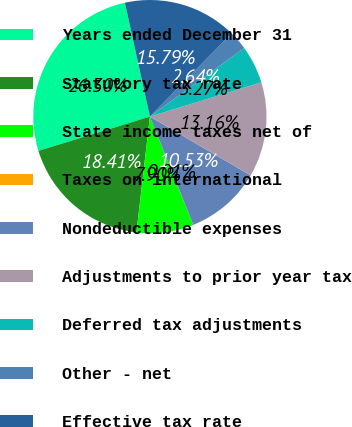Convert chart. <chart><loc_0><loc_0><loc_500><loc_500><pie_chart><fcel>Years ended December 31<fcel>Statutory tax rate<fcel>State income taxes net of<fcel>Taxes on international<fcel>Nondeductible expenses<fcel>Adjustments to prior year tax<fcel>Deferred tax adjustments<fcel>Other - net<fcel>Effective tax rate<nl><fcel>26.31%<fcel>18.42%<fcel>7.9%<fcel>0.01%<fcel>10.53%<fcel>13.16%<fcel>5.27%<fcel>2.64%<fcel>15.79%<nl></chart> 